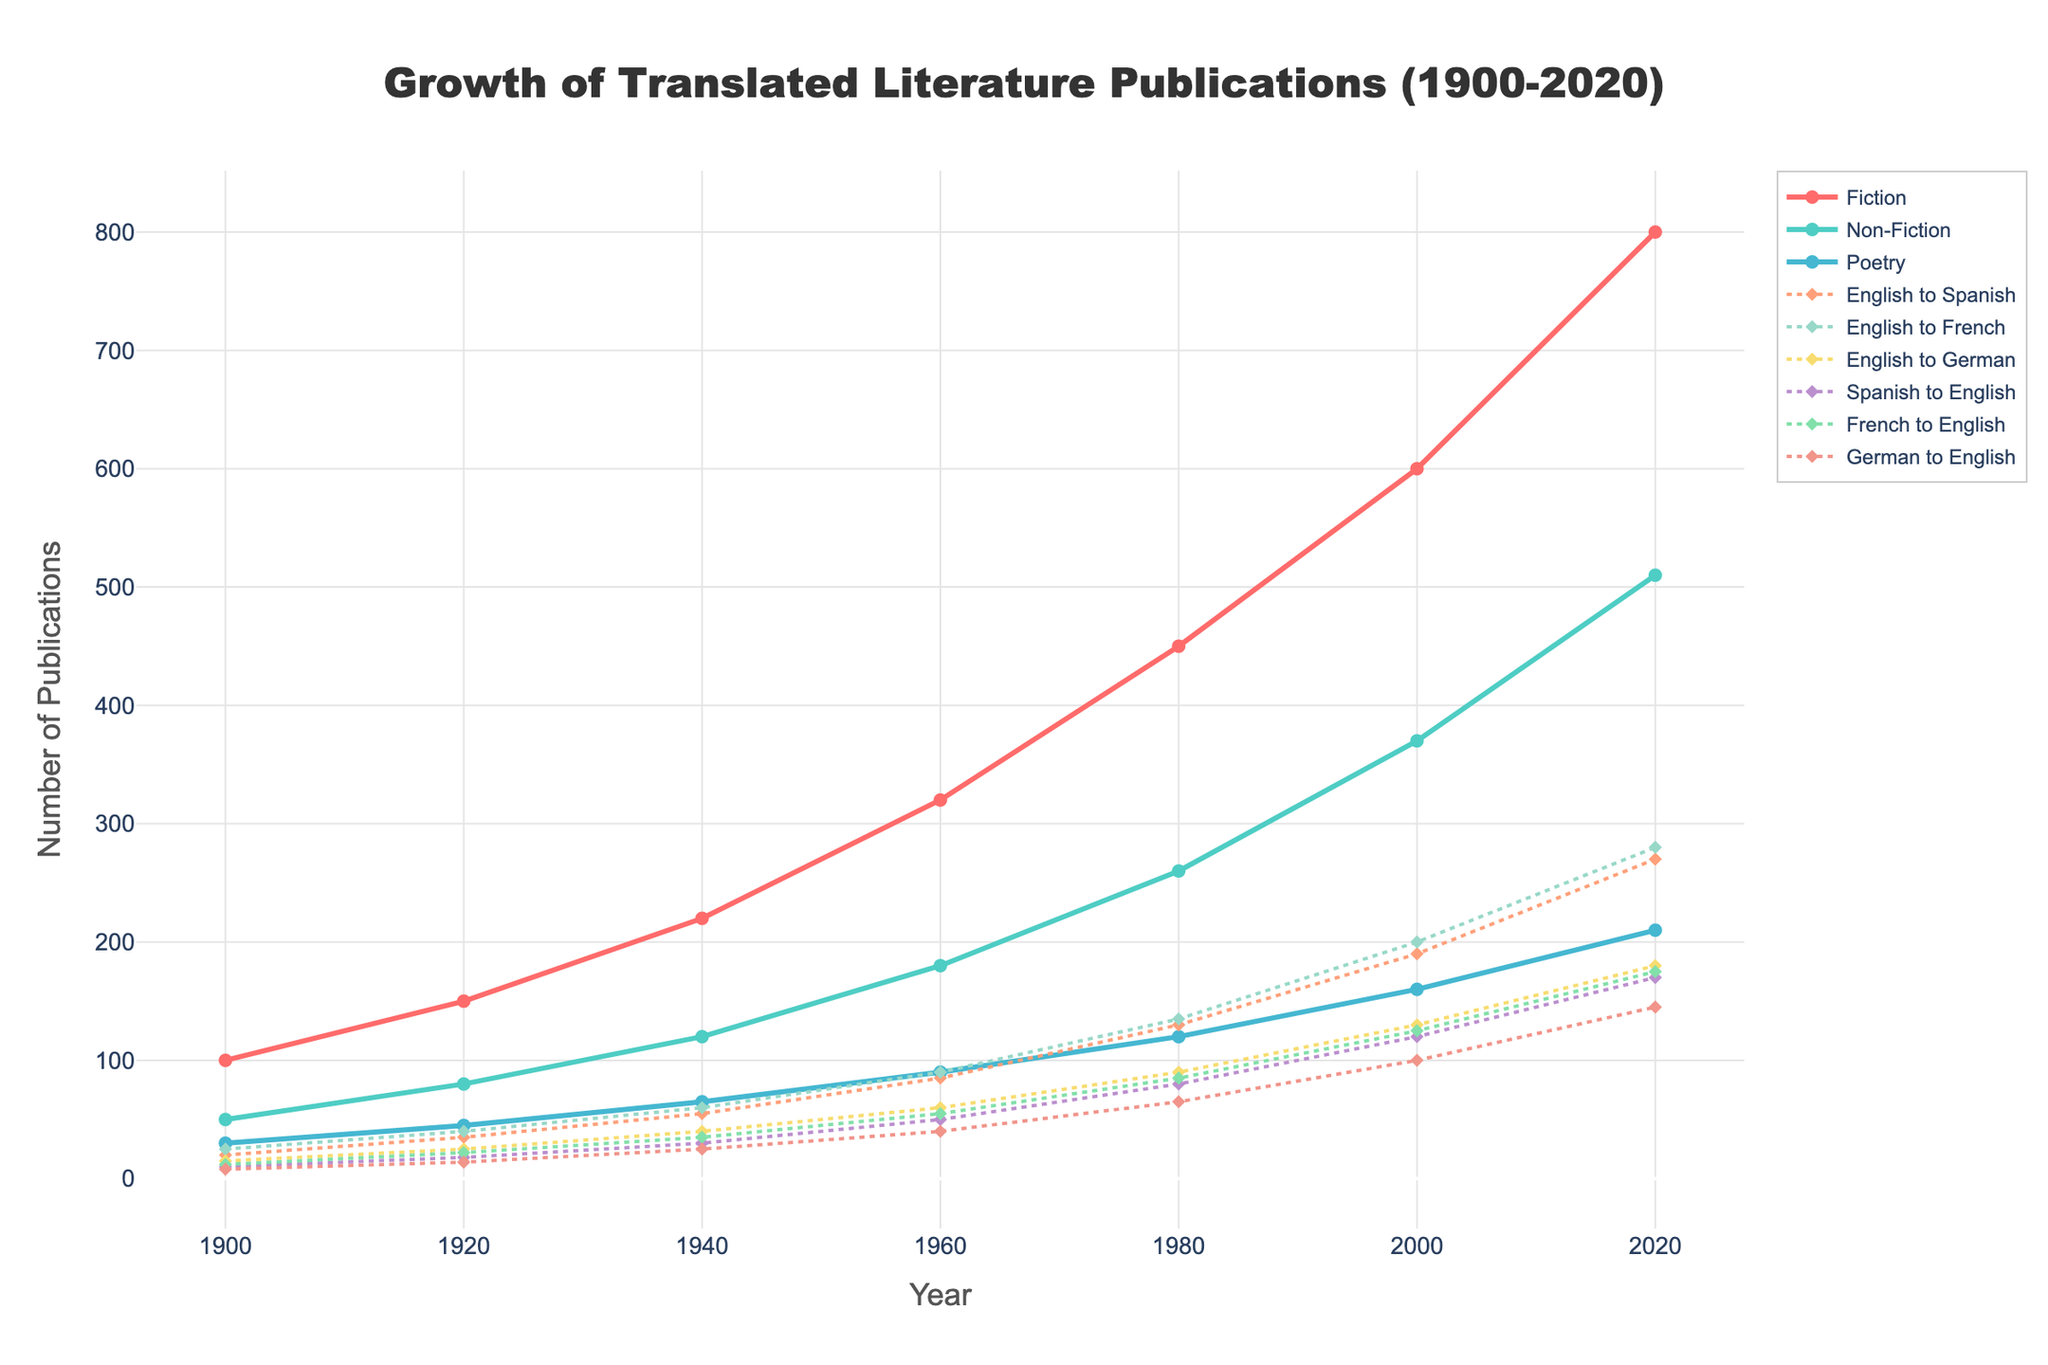What genre shows the highest number of publications in 2020? Look at the values for Fiction, Non-Fiction, and Poetry in 2020. Fiction has the highest value at 800 publications.
Answer: Fiction How many more Fiction publications were there in 2020 compared to 2000? Compare the values for Fiction in 2020 and 2000. The difference is 800 - 600 = 200.
Answer: 200 Which translation type witnessed the largest increase between 2000 and 2020? Calculate the difference for each translation type between 2000 and 2020. "English to Spanish" shows the largest increase from 190 to 270, which is an 80 publication increase.
Answer: English to Spanish What's the total number of Non-Fiction publications in 1900, 1940, and 1980? Sum the values for Non-Fiction in 1900 (50), 1940 (120), and 1980 (260). The total is 50 + 120 + 260 = 430.
Answer: 430 In 1980, how did the number of Poetry publications compare to English to French translations? Check the values for Poetry and English to French translations in 1980. Poetry has 120 publications, and English to French has 135.
Answer: English to French had more What is the average number of German to English publications from 1900 to 2020? Add the values for German to English publications across all years and divide by the number of years (9 + 14 + 25 + 40 + 65 + 100 + 145) / 7 = 398 / 7 ≈ 56.86.
Answer: 56.86 Between 1960 and 1980, which genre saw the highest growth in publications? Calculate the growth for each genre (1980 value minus 1960 value): Fiction (450 - 320 = 130), Non-Fiction (260 - 180 = 80), Poetry (120 - 90 = 30). Fiction has the highest growth.
Answer: Fiction Looking at the data for English to German translations, describe the trend from 1900 to 2020. The number of English to German translations increased from 15 in 1900 to 180 in 2020. This shows a steady growth over time.
Answer: Steady growth Which year had more French to English translations compared to Spanish to English translations? Compare the values of French to English and Spanish to English in 1900, 1920, and 1940. French to English had more in the year 1920.
Answer: 1920 